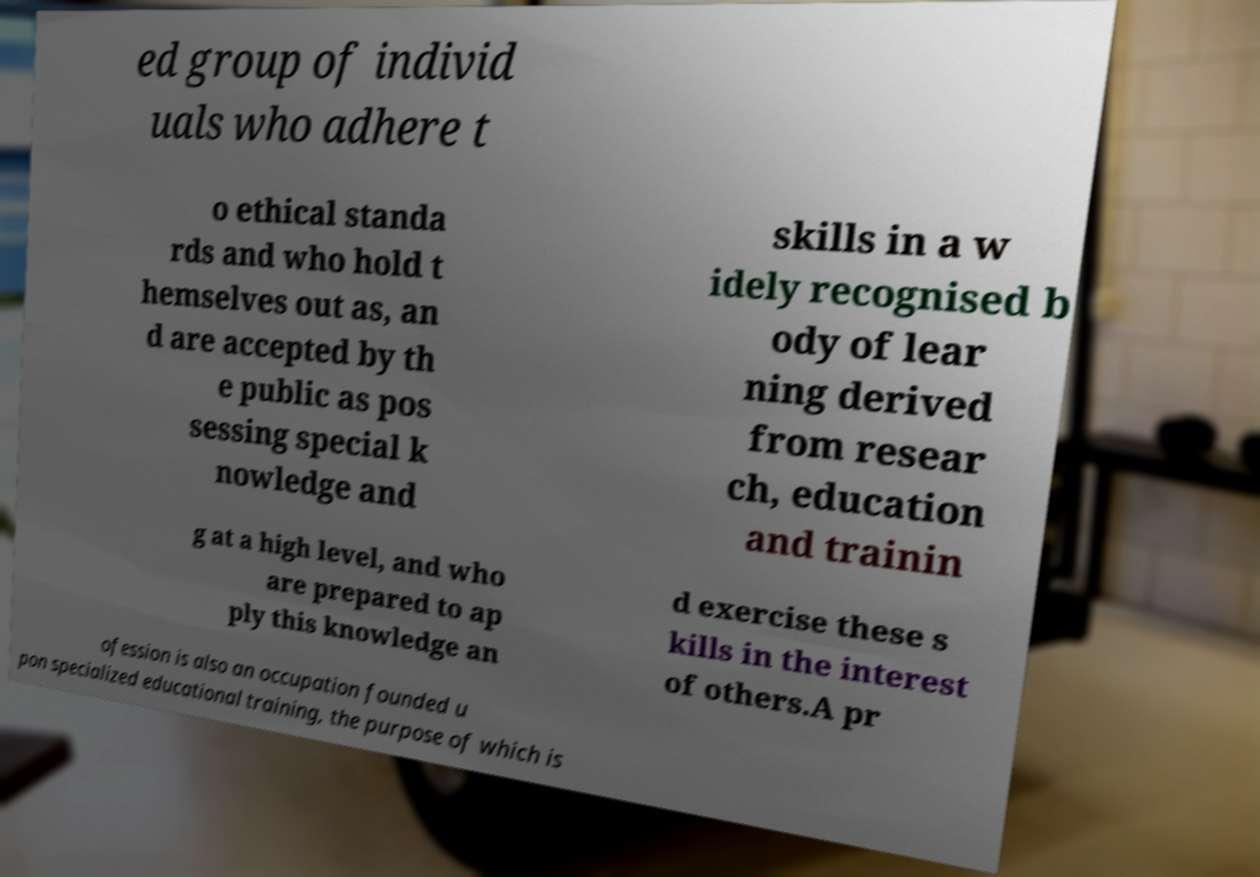Can you read and provide the text displayed in the image?This photo seems to have some interesting text. Can you extract and type it out for me? ed group of individ uals who adhere t o ethical standa rds and who hold t hemselves out as, an d are accepted by th e public as pos sessing special k nowledge and skills in a w idely recognised b ody of lear ning derived from resear ch, education and trainin g at a high level, and who are prepared to ap ply this knowledge an d exercise these s kills in the interest of others.A pr ofession is also an occupation founded u pon specialized educational training, the purpose of which is 